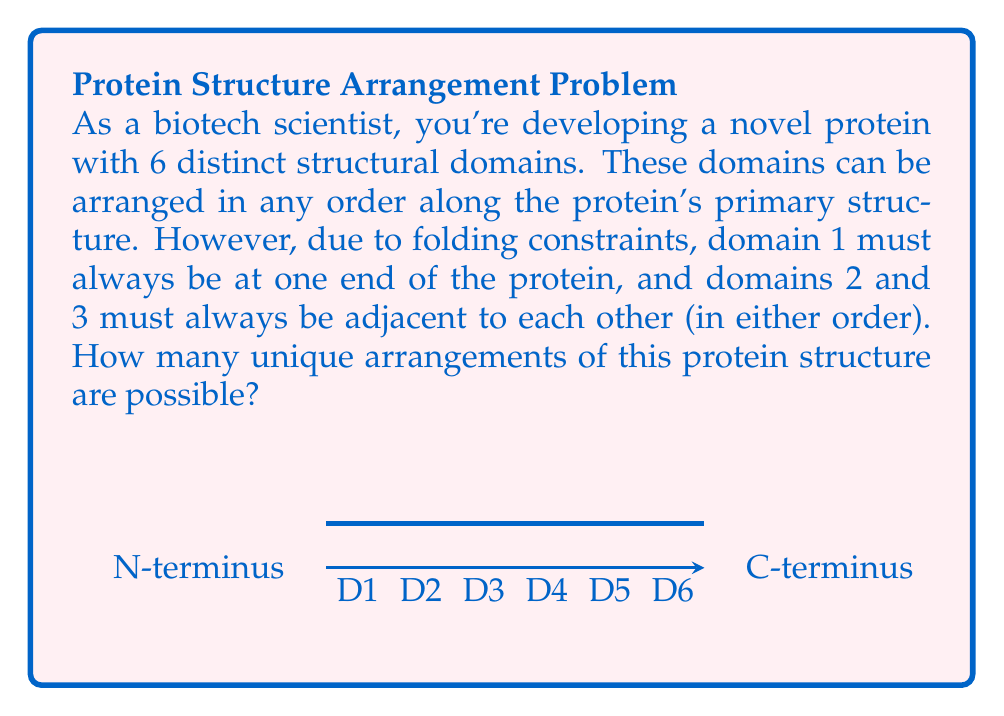Can you solve this math problem? Let's approach this step-by-step:

1) First, we need to consider the constraints:
   - Domain 1 must be at one end
   - Domains 2 and 3 must be adjacent

2) We can treat domains 2 and 3 as a single unit, let's call it unit X. So now we have 5 elements to arrange: 1, X, 4, 5, 6.

3) Domain 1 can be at either end, so we have two cases:
   Case A: 1 at the start
   Case B: 1 at the end

4) For Case A:
   - We have 1 fixed, and need to arrange X, 4, 5, 6
   - This is a straightforward permutation: $4! = 24$

5) For Case B:
   - We have 1 fixed at the end, and need to arrange X, 4, 5, 6
   - Again, this is $4! = 24$

6) However, remember that X represents two domains (2 and 3) that can be in either order. So for each arrangement we've counted so far, there are actually 2 possible arrangements of X.

7) Therefore, the total number of arrangements is:
   $$(24 + 24) * 2 = 96$$

Thus, there are 96 unique arrangements of this protein structure.
Answer: 96 